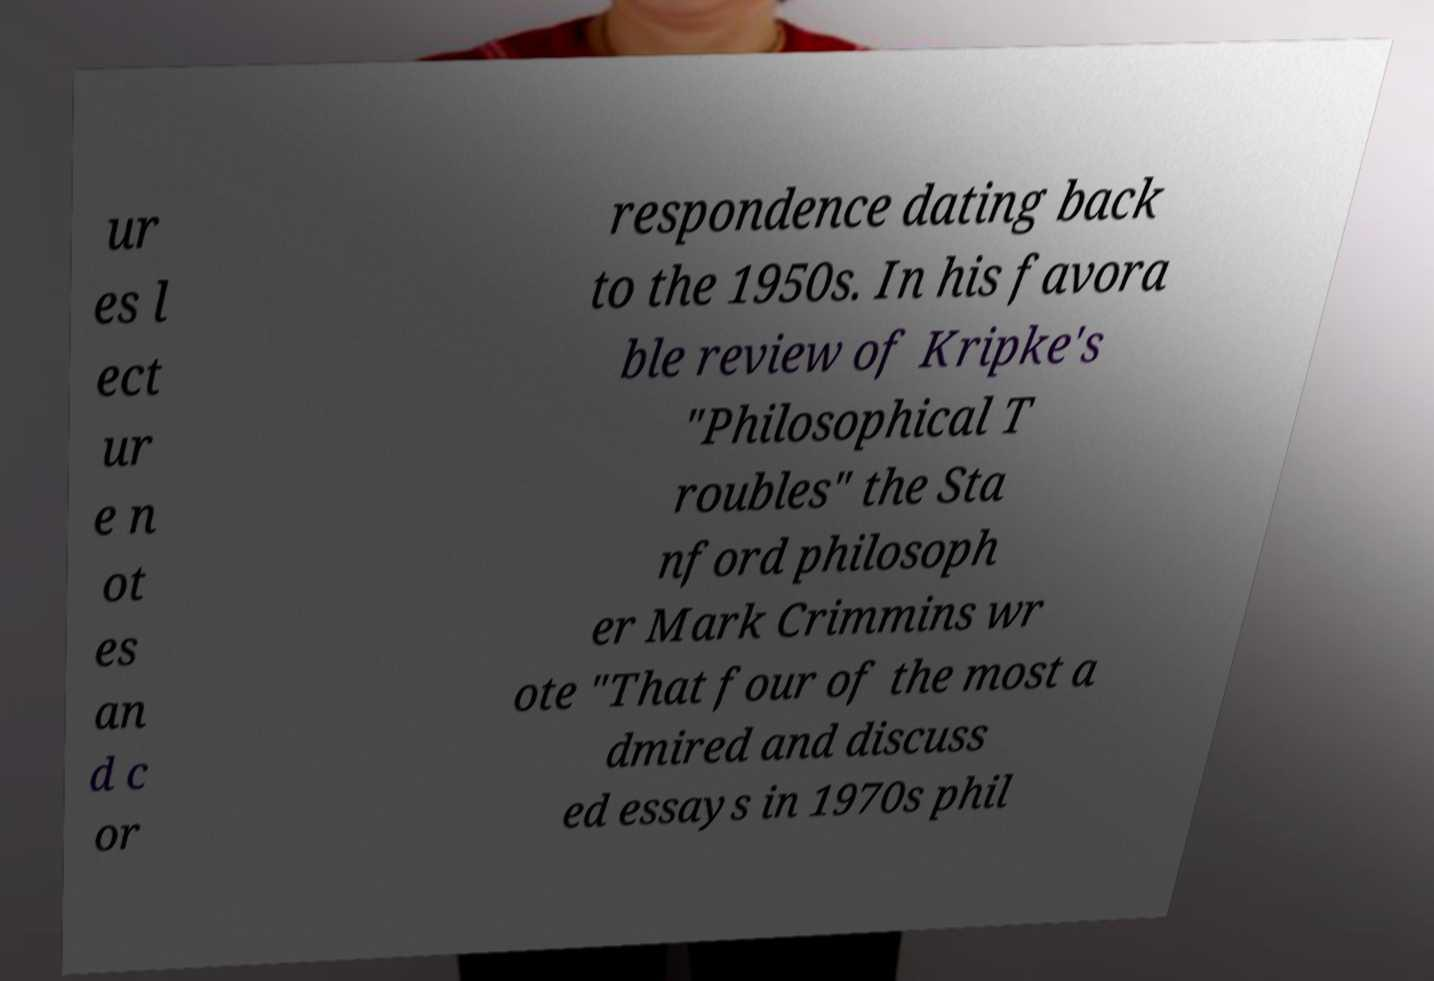Can you read and provide the text displayed in the image?This photo seems to have some interesting text. Can you extract and type it out for me? ur es l ect ur e n ot es an d c or respondence dating back to the 1950s. In his favora ble review of Kripke's "Philosophical T roubles" the Sta nford philosoph er Mark Crimmins wr ote "That four of the most a dmired and discuss ed essays in 1970s phil 